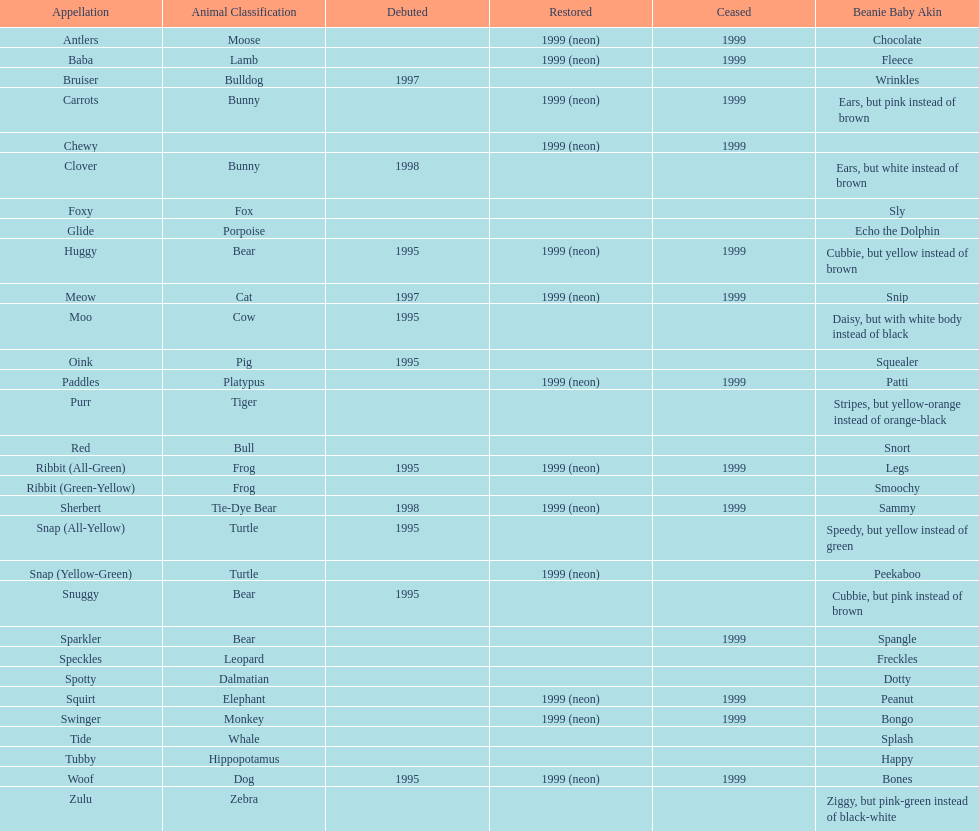Give me the full table as a dictionary. {'header': ['Appellation', 'Animal Classification', 'Debuted', 'Restored', 'Ceased', 'Beanie Baby Akin'], 'rows': [['Antlers', 'Moose', '', '1999 (neon)', '1999', 'Chocolate'], ['Baba', 'Lamb', '', '1999 (neon)', '1999', 'Fleece'], ['Bruiser', 'Bulldog', '1997', '', '', 'Wrinkles'], ['Carrots', 'Bunny', '', '1999 (neon)', '1999', 'Ears, but pink instead of brown'], ['Chewy', '', '', '1999 (neon)', '1999', ''], ['Clover', 'Bunny', '1998', '', '', 'Ears, but white instead of brown'], ['Foxy', 'Fox', '', '', '', 'Sly'], ['Glide', 'Porpoise', '', '', '', 'Echo the Dolphin'], ['Huggy', 'Bear', '1995', '1999 (neon)', '1999', 'Cubbie, but yellow instead of brown'], ['Meow', 'Cat', '1997', '1999 (neon)', '1999', 'Snip'], ['Moo', 'Cow', '1995', '', '', 'Daisy, but with white body instead of black'], ['Oink', 'Pig', '1995', '', '', 'Squealer'], ['Paddles', 'Platypus', '', '1999 (neon)', '1999', 'Patti'], ['Purr', 'Tiger', '', '', '', 'Stripes, but yellow-orange instead of orange-black'], ['Red', 'Bull', '', '', '', 'Snort'], ['Ribbit (All-Green)', 'Frog', '1995', '1999 (neon)', '1999', 'Legs'], ['Ribbit (Green-Yellow)', 'Frog', '', '', '', 'Smoochy'], ['Sherbert', 'Tie-Dye Bear', '1998', '1999 (neon)', '1999', 'Sammy'], ['Snap (All-Yellow)', 'Turtle', '1995', '', '', 'Speedy, but yellow instead of green'], ['Snap (Yellow-Green)', 'Turtle', '', '1999 (neon)', '', 'Peekaboo'], ['Snuggy', 'Bear', '1995', '', '', 'Cubbie, but pink instead of brown'], ['Sparkler', 'Bear', '', '', '1999', 'Spangle'], ['Speckles', 'Leopard', '', '', '', 'Freckles'], ['Spotty', 'Dalmatian', '', '', '', 'Dotty'], ['Squirt', 'Elephant', '', '1999 (neon)', '1999', 'Peanut'], ['Swinger', 'Monkey', '', '1999 (neon)', '1999', 'Bongo'], ['Tide', 'Whale', '', '', '', 'Splash'], ['Tubby', 'Hippopotamus', '', '', '', 'Happy'], ['Woof', 'Dog', '1995', '1999 (neon)', '1999', 'Bones'], ['Zulu', 'Zebra', '', '', '', 'Ziggy, but pink-green instead of black-white']]} In what year were the first pillow pals introduced? 1995. 